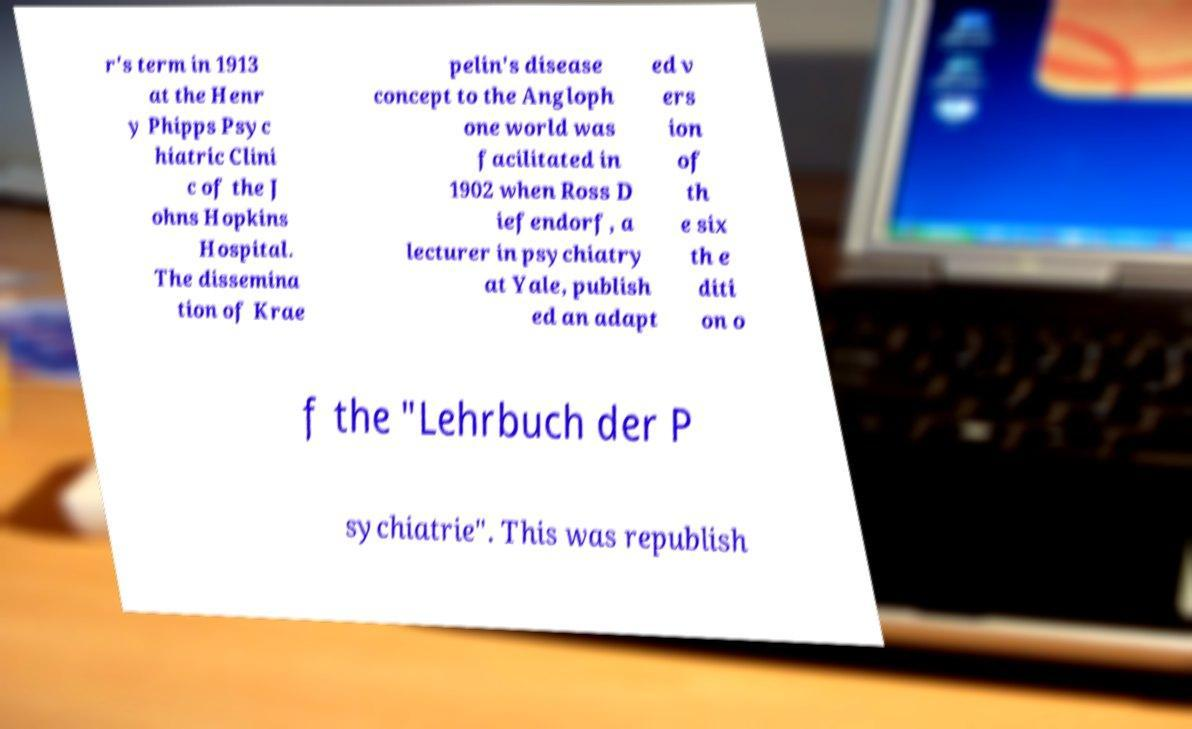Please identify and transcribe the text found in this image. r's term in 1913 at the Henr y Phipps Psyc hiatric Clini c of the J ohns Hopkins Hospital. The dissemina tion of Krae pelin's disease concept to the Angloph one world was facilitated in 1902 when Ross D iefendorf, a lecturer in psychiatry at Yale, publish ed an adapt ed v ers ion of th e six th e diti on o f the "Lehrbuch der P sychiatrie". This was republish 